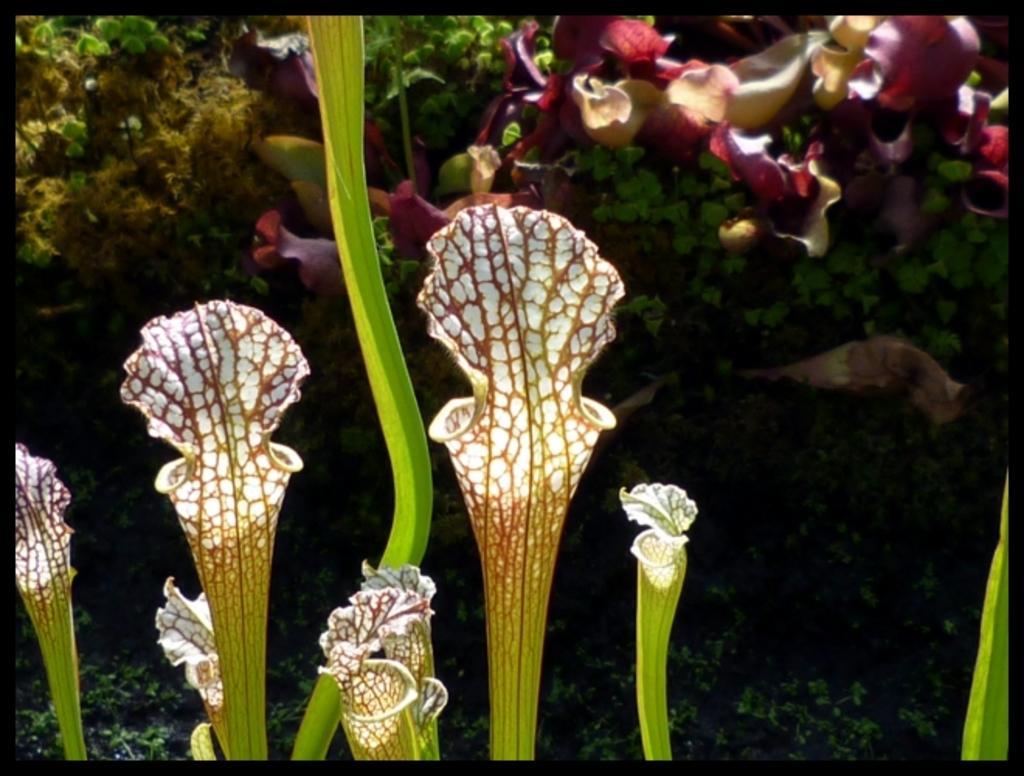Could you give a brief overview of what you see in this image? In this image we can see some flowers and plants which are of different colors like green, pink, yellow, white and some other color. 